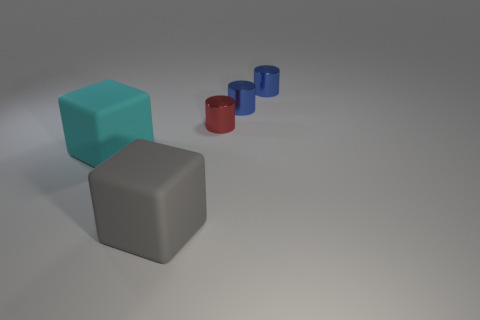Add 3 tiny red metallic things. How many objects exist? 8 Subtract all blocks. How many objects are left? 3 Add 1 tiny blue shiny objects. How many tiny blue shiny objects exist? 3 Subtract 0 green balls. How many objects are left? 5 Subtract all small things. Subtract all small red shiny things. How many objects are left? 1 Add 3 large matte things. How many large matte things are left? 5 